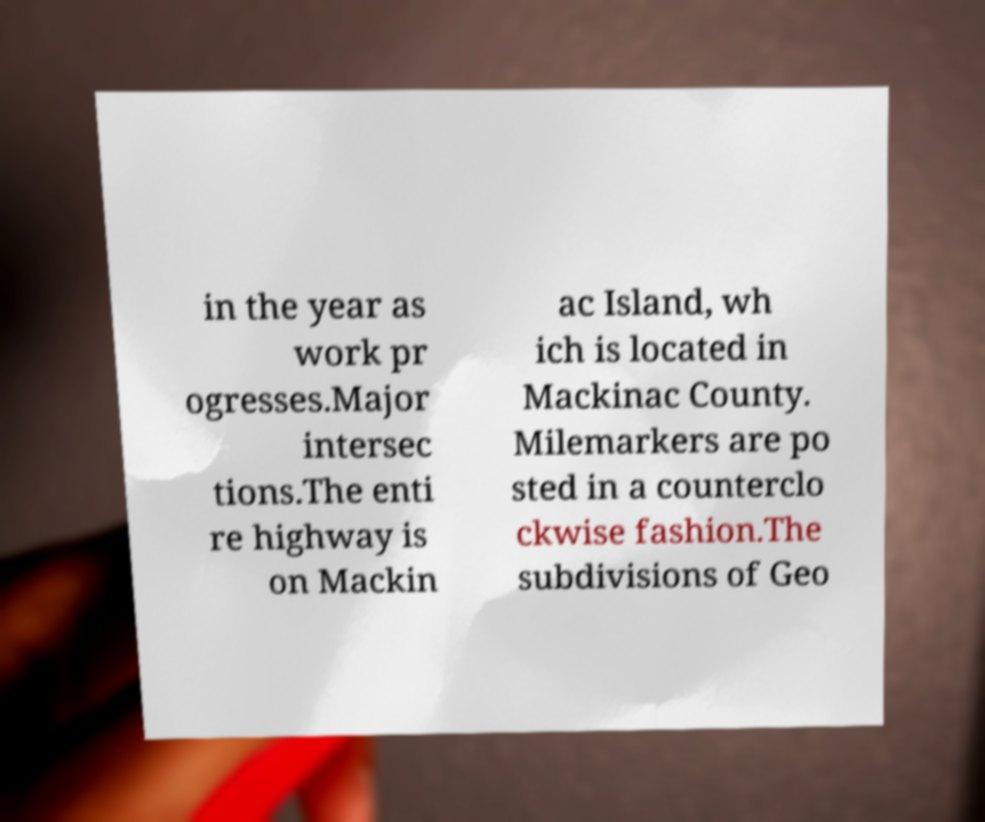Could you extract and type out the text from this image? in the year as work pr ogresses.Major intersec tions.The enti re highway is on Mackin ac Island, wh ich is located in Mackinac County. Milemarkers are po sted in a counterclo ckwise fashion.The subdivisions of Geo 